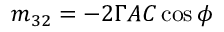Convert formula to latex. <formula><loc_0><loc_0><loc_500><loc_500>m _ { 3 2 } = - 2 \Gamma A C \cos \phi</formula> 